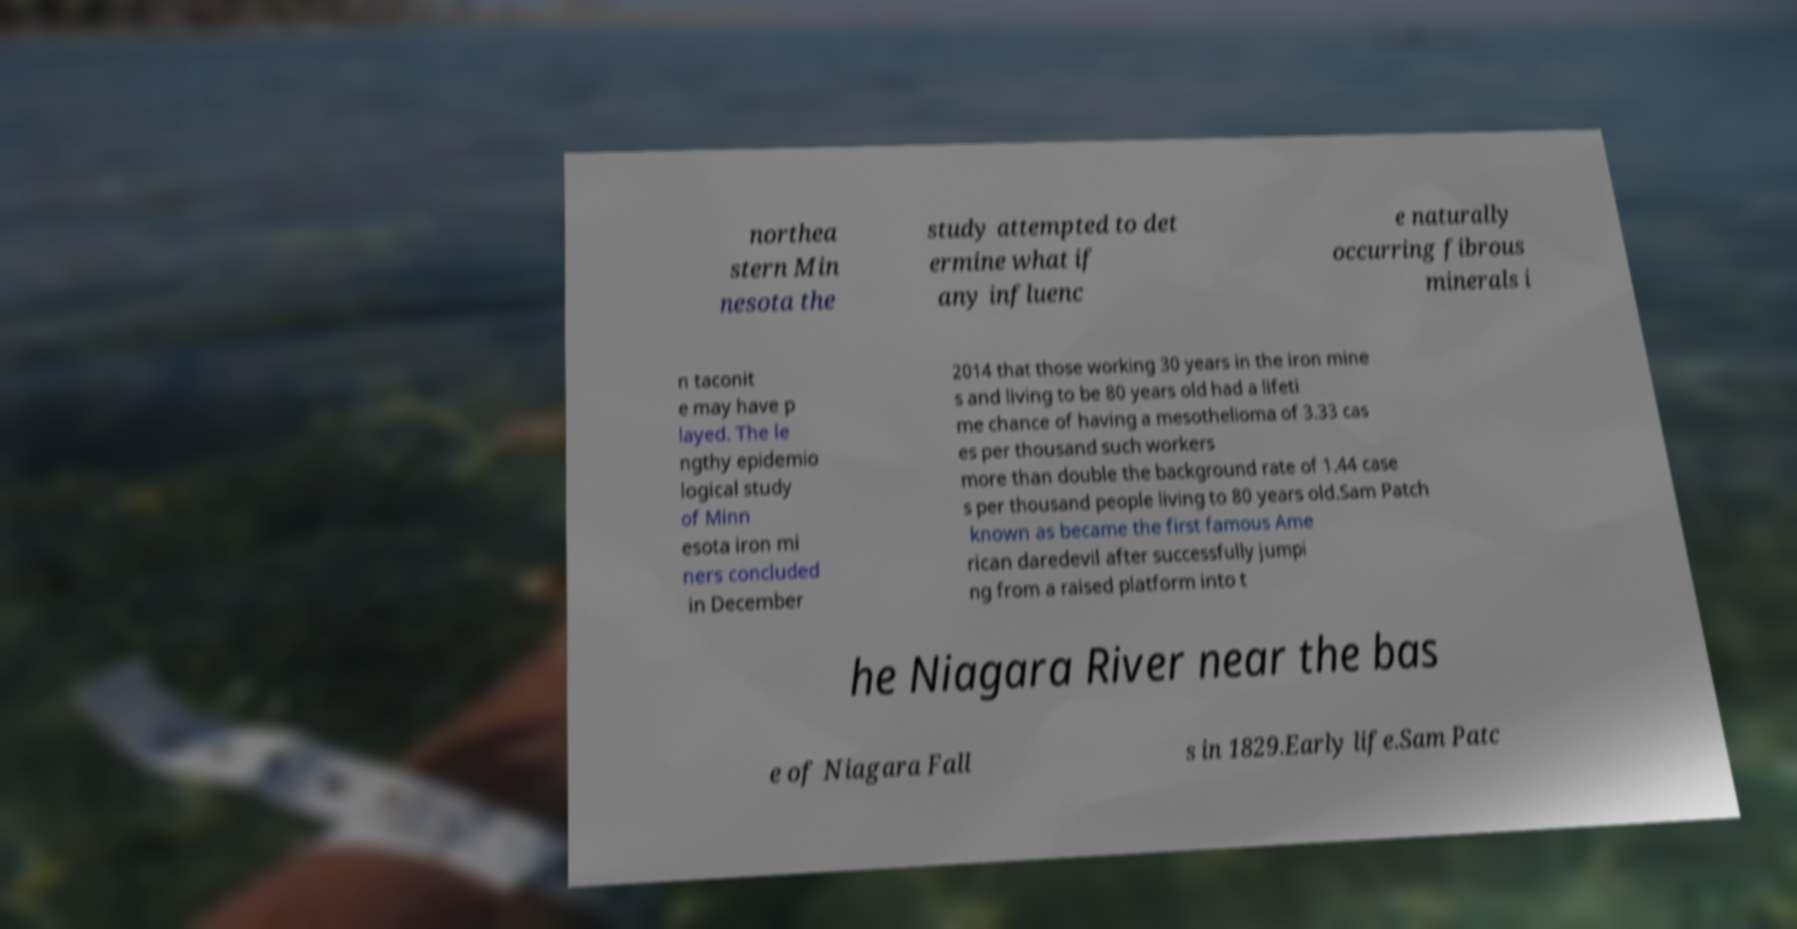For documentation purposes, I need the text within this image transcribed. Could you provide that? northea stern Min nesota the study attempted to det ermine what if any influenc e naturally occurring fibrous minerals i n taconit e may have p layed. The le ngthy epidemio logical study of Minn esota iron mi ners concluded in December 2014 that those working 30 years in the iron mine s and living to be 80 years old had a lifeti me chance of having a mesothelioma of 3.33 cas es per thousand such workers more than double the background rate of 1.44 case s per thousand people living to 80 years old.Sam Patch known as became the first famous Ame rican daredevil after successfully jumpi ng from a raised platform into t he Niagara River near the bas e of Niagara Fall s in 1829.Early life.Sam Patc 